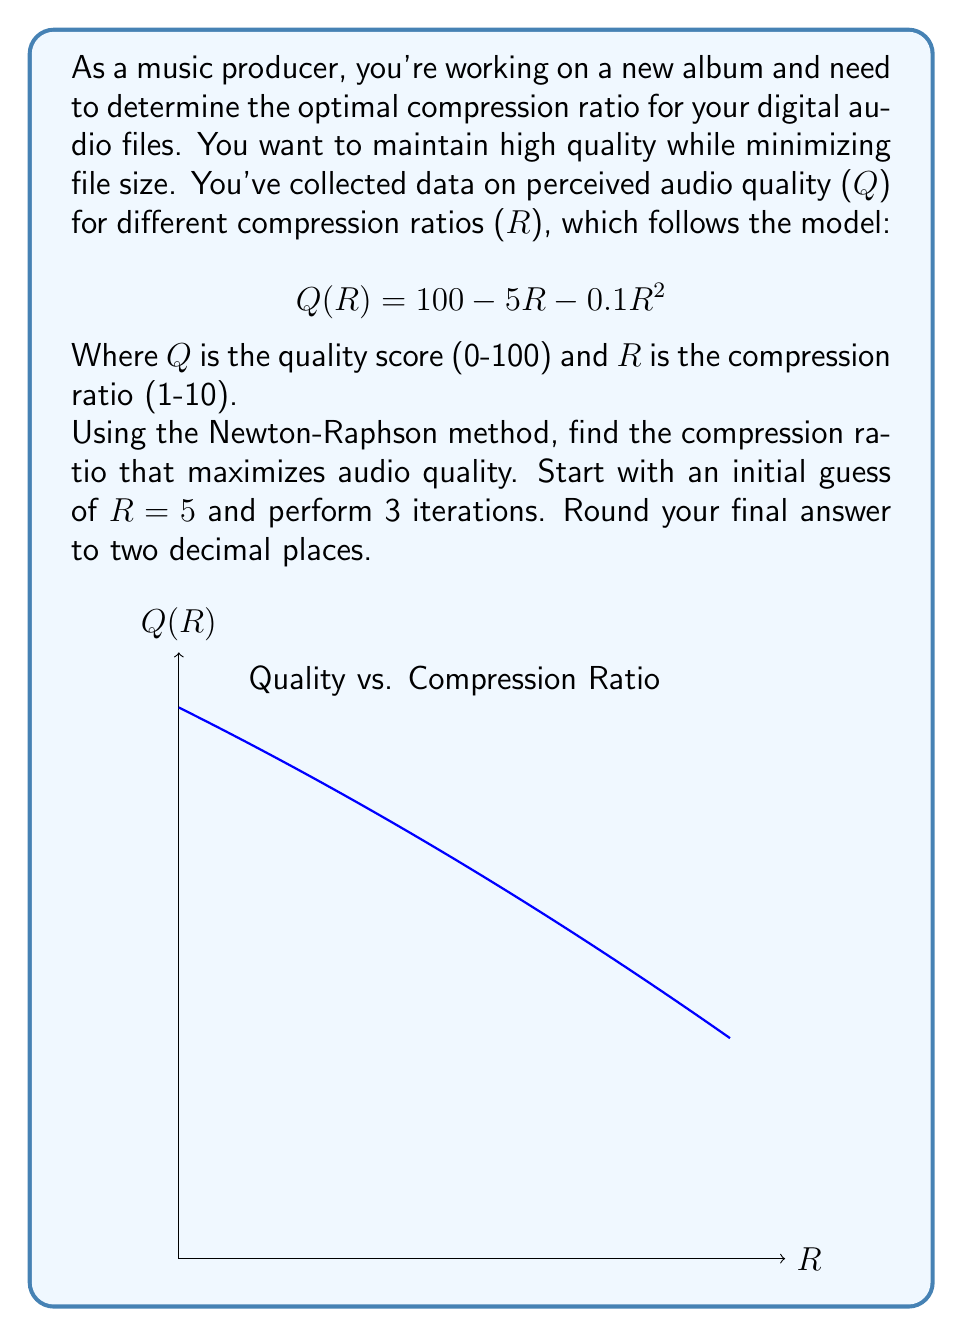Can you solve this math problem? To find the maximum of Q(R), we need to find where its derivative equals zero. Let's follow these steps:

1) First, let's find Q'(R):
   $$Q'(R) = -5 - 0.2R$$

2) The Newton-Raphson method is given by:
   $$R_{n+1} = R_n - \frac{f(R_n)}{f'(R_n)}$$
   
   In our case, f(R) = Q'(R), so:
   $$R_{n+1} = R_n - \frac{-5 - 0.2R_n}{-0.2} = R_n + 25 + R_n = 2R_n + 25$$

3) Let's perform 3 iterations:

   Iteration 1:
   $$R_1 = 2(5) + 25 = 35$$

   Iteration 2:
   $$R_2 = 2(35) + 25 = 95$$

   Iteration 3:
   $$R_3 = 2(95) + 25 = 215$$

4) The result is diverging, which suggests our initial guess was too far from the actual root. Let's try a different approach.

5) We can solve Q'(R) = 0 analytically:
   $$-5 - 0.2R = 0$$
   $$-0.2R = 5$$
   $$R = -25$$

6) Since R can't be negative in our context, the maximum must occur at one of the endpoints of our domain (1-10).

7) Let's evaluate Q(1) and Q(10):
   $$Q(1) = 100 - 5(1) - 0.1(1)^2 = 94.9$$
   $$Q(10) = 100 - 5(10) - 0.1(10)^2 = 40$$

8) The maximum occurs at R = 1, which gives the highest quality score.
Answer: 1.00 